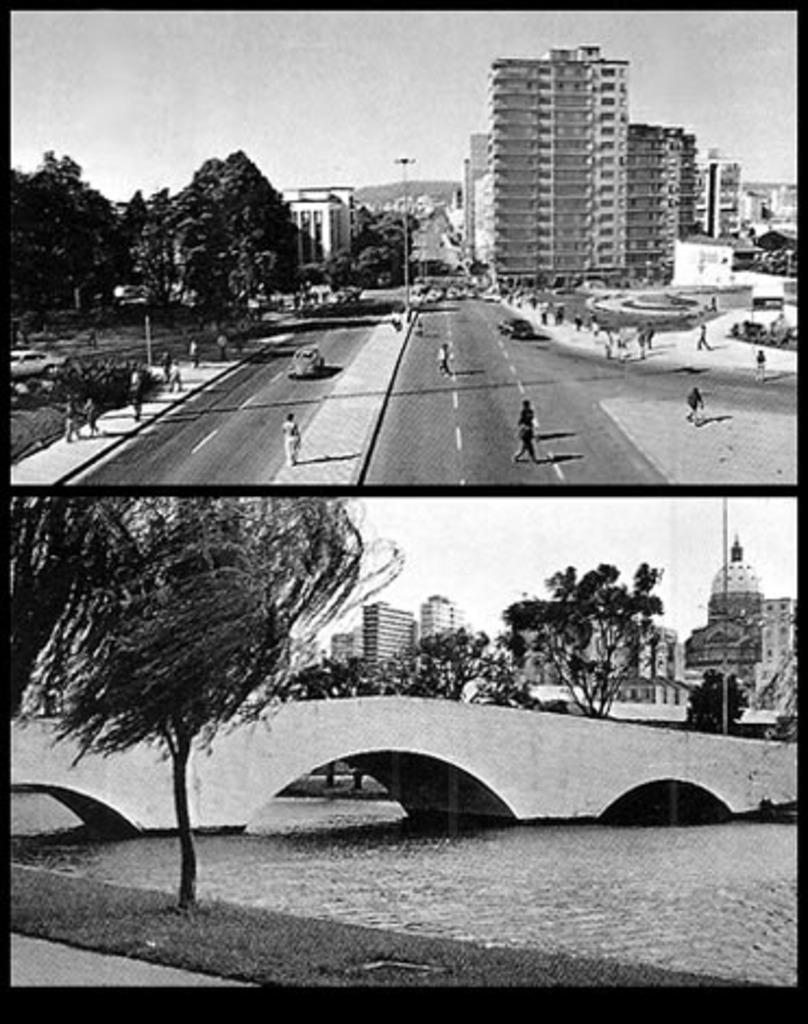How would you summarize this image in a sentence or two? This is a collage, in this image at the bottom there is a bridge, river, trees, buildings and some poles. At the top of the image there are some buildings, trees, poles, vehicles and some persons are walking on a road and at the top there is sky. 